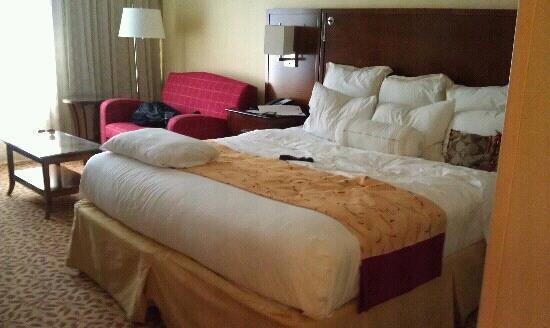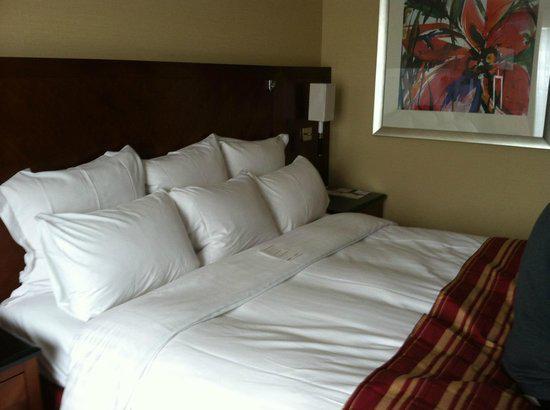The first image is the image on the left, the second image is the image on the right. For the images displayed, is the sentence "There are exactly two table lamps in the image on the left." factually correct? Answer yes or no. No. 